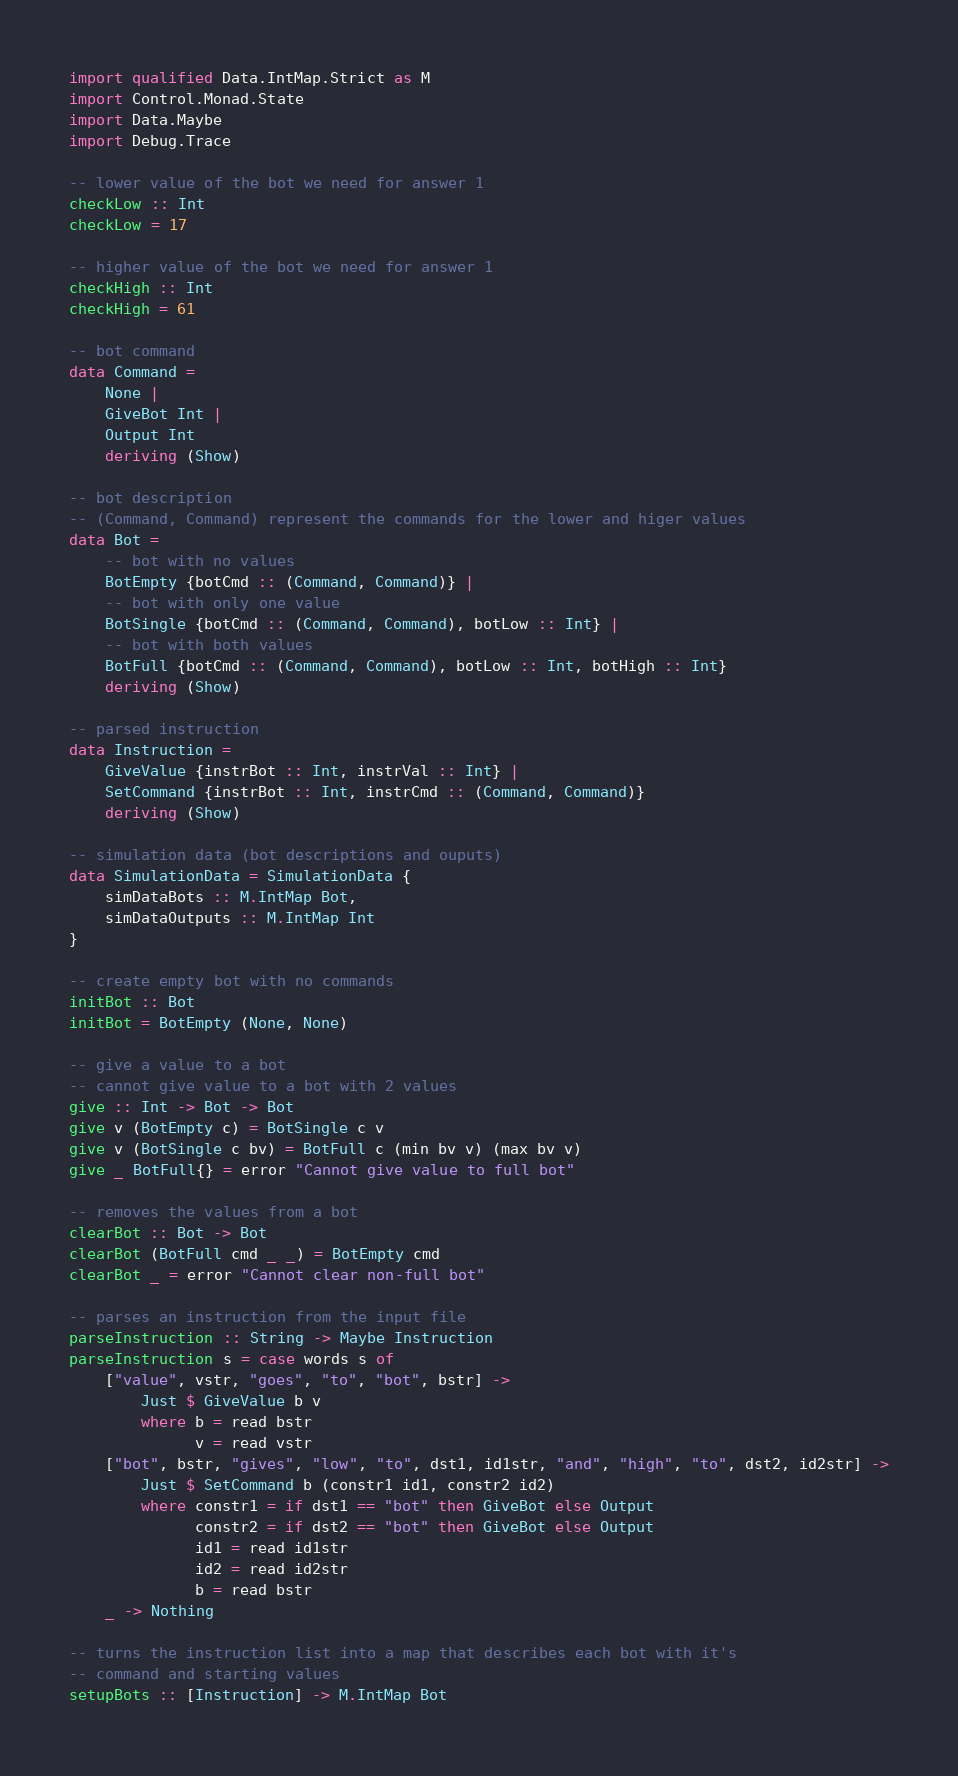Convert code to text. <code><loc_0><loc_0><loc_500><loc_500><_Haskell_>import qualified Data.IntMap.Strict as M
import Control.Monad.State
import Data.Maybe
import Debug.Trace

-- lower value of the bot we need for answer 1
checkLow :: Int
checkLow = 17

-- higher value of the bot we need for answer 1
checkHigh :: Int
checkHigh = 61

-- bot command
data Command =
    None |
    GiveBot Int |
    Output Int
    deriving (Show)

-- bot description
-- (Command, Command) represent the commands for the lower and higer values
data Bot =
    -- bot with no values
    BotEmpty {botCmd :: (Command, Command)} |
    -- bot with only one value
    BotSingle {botCmd :: (Command, Command), botLow :: Int} |
    -- bot with both values
    BotFull {botCmd :: (Command, Command), botLow :: Int, botHigh :: Int}
    deriving (Show)

-- parsed instruction
data Instruction =
    GiveValue {instrBot :: Int, instrVal :: Int} |
    SetCommand {instrBot :: Int, instrCmd :: (Command, Command)}
    deriving (Show)

-- simulation data (bot descriptions and ouputs)
data SimulationData = SimulationData {
    simDataBots :: M.IntMap Bot,
    simDataOutputs :: M.IntMap Int
}

-- create empty bot with no commands
initBot :: Bot
initBot = BotEmpty (None, None)

-- give a value to a bot
-- cannot give value to a bot with 2 values
give :: Int -> Bot -> Bot
give v (BotEmpty c) = BotSingle c v
give v (BotSingle c bv) = BotFull c (min bv v) (max bv v)
give _ BotFull{} = error "Cannot give value to full bot"

-- removes the values from a bot
clearBot :: Bot -> Bot
clearBot (BotFull cmd _ _) = BotEmpty cmd
clearBot _ = error "Cannot clear non-full bot"

-- parses an instruction from the input file
parseInstruction :: String -> Maybe Instruction
parseInstruction s = case words s of
    ["value", vstr, "goes", "to", "bot", bstr] ->
        Just $ GiveValue b v
        where b = read bstr
              v = read vstr
    ["bot", bstr, "gives", "low", "to", dst1, id1str, "and", "high", "to", dst2, id2str] ->
        Just $ SetCommand b (constr1 id1, constr2 id2)
        where constr1 = if dst1 == "bot" then GiveBot else Output
              constr2 = if dst2 == "bot" then GiveBot else Output
              id1 = read id1str
              id2 = read id2str
              b = read bstr
    _ -> Nothing

-- turns the instruction list into a map that describes each bot with it's
-- command and starting values
setupBots :: [Instruction] -> M.IntMap Bot</code> 